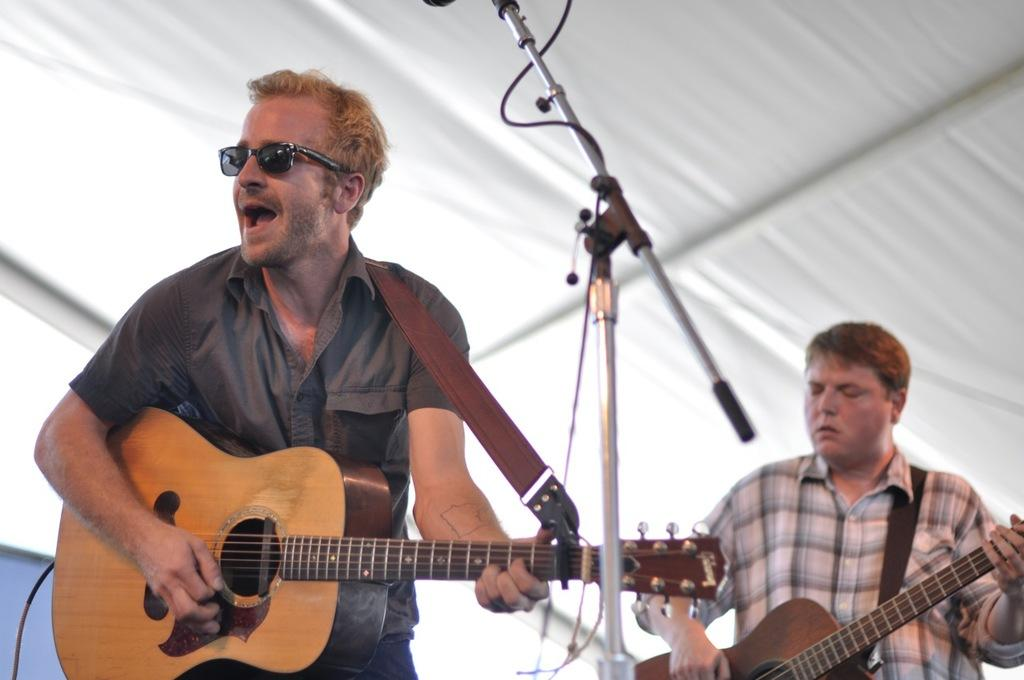What is the man in the image doing? The man in the image is singing and playing a guitar. How is the man's voice being amplified in the image? The man is using a microphone in the image. Are there any other musicians in the image? Yes, there is another man playing a guitar in the image. What type of steel is the guitar made of in the image? There is no information about the guitar's material in the image, so it cannot be determined if it is made of steel. 